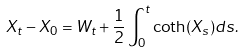Convert formula to latex. <formula><loc_0><loc_0><loc_500><loc_500>X _ { t } - X _ { 0 } = W _ { t } + \frac { 1 } { 2 } \int _ { 0 } ^ { t } \coth ( X _ { s } ) d s .</formula> 